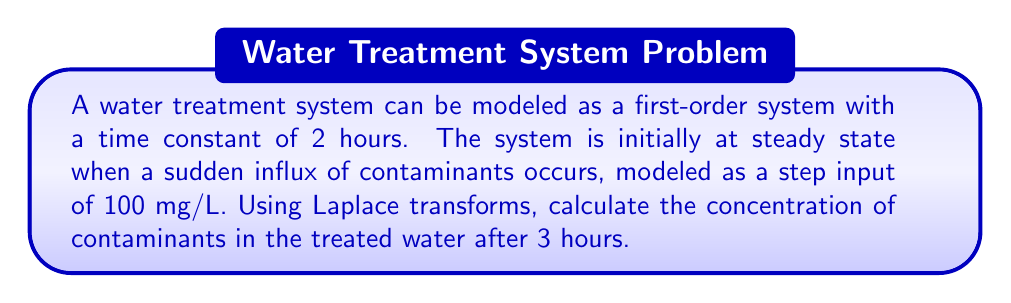Give your solution to this math problem. To solve this problem, we'll use the following steps:

1) The transfer function of a first-order system is given by:

   $$G(s) = \frac{K}{\tau s + 1}$$

   where $K$ is the steady-state gain (1 in this case) and $\tau$ is the time constant (2 hours).

2) The input is a step function of magnitude 100 mg/L. The Laplace transform of a step function is:

   $$U(s) = \frac{100}{s}$$

3) The output in the s-domain is the product of the input and the transfer function:

   $$Y(s) = U(s) \cdot G(s) = \frac{100}{s} \cdot \frac{1}{2s + 1} = \frac{100}{s(2s + 1)}$$

4) To find the time-domain response, we need to perform partial fraction decomposition:

   $$\frac{100}{s(2s + 1)} = \frac{A}{s} + \frac{B}{2s + 1}$$

   Solving for A and B:
   
   $$A = 100, B = -100$$

5) Now we can write the output as:

   $$Y(s) = \frac{100}{s} - \frac{100}{2s + 1}$$

6) Taking the inverse Laplace transform:

   $$y(t) = 100 - 100e^{-t/2}$$

7) To find the concentration after 3 hours, we substitute $t = 3$:

   $$y(3) = 100 - 100e^{-3/2} \approx 77.69 \text{ mg/L}$$
Answer: The concentration of contaminants in the treated water after 3 hours is approximately 77.69 mg/L. 